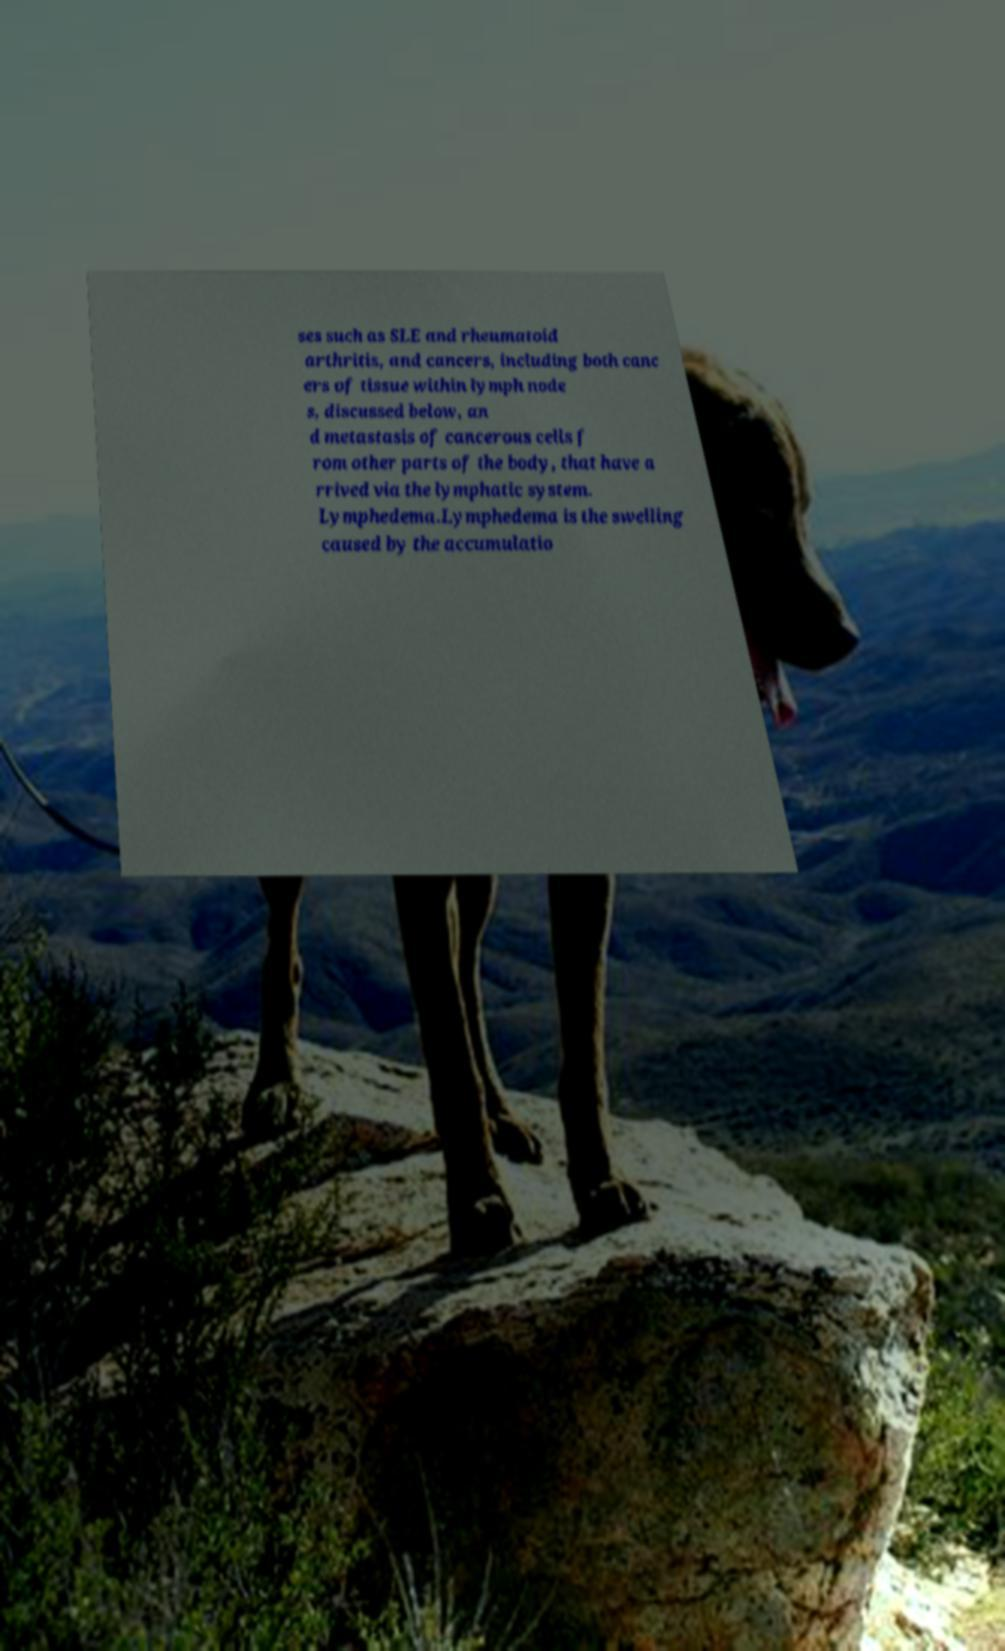Could you extract and type out the text from this image? ses such as SLE and rheumatoid arthritis, and cancers, including both canc ers of tissue within lymph node s, discussed below, an d metastasis of cancerous cells f rom other parts of the body, that have a rrived via the lymphatic system. Lymphedema.Lymphedema is the swelling caused by the accumulatio 